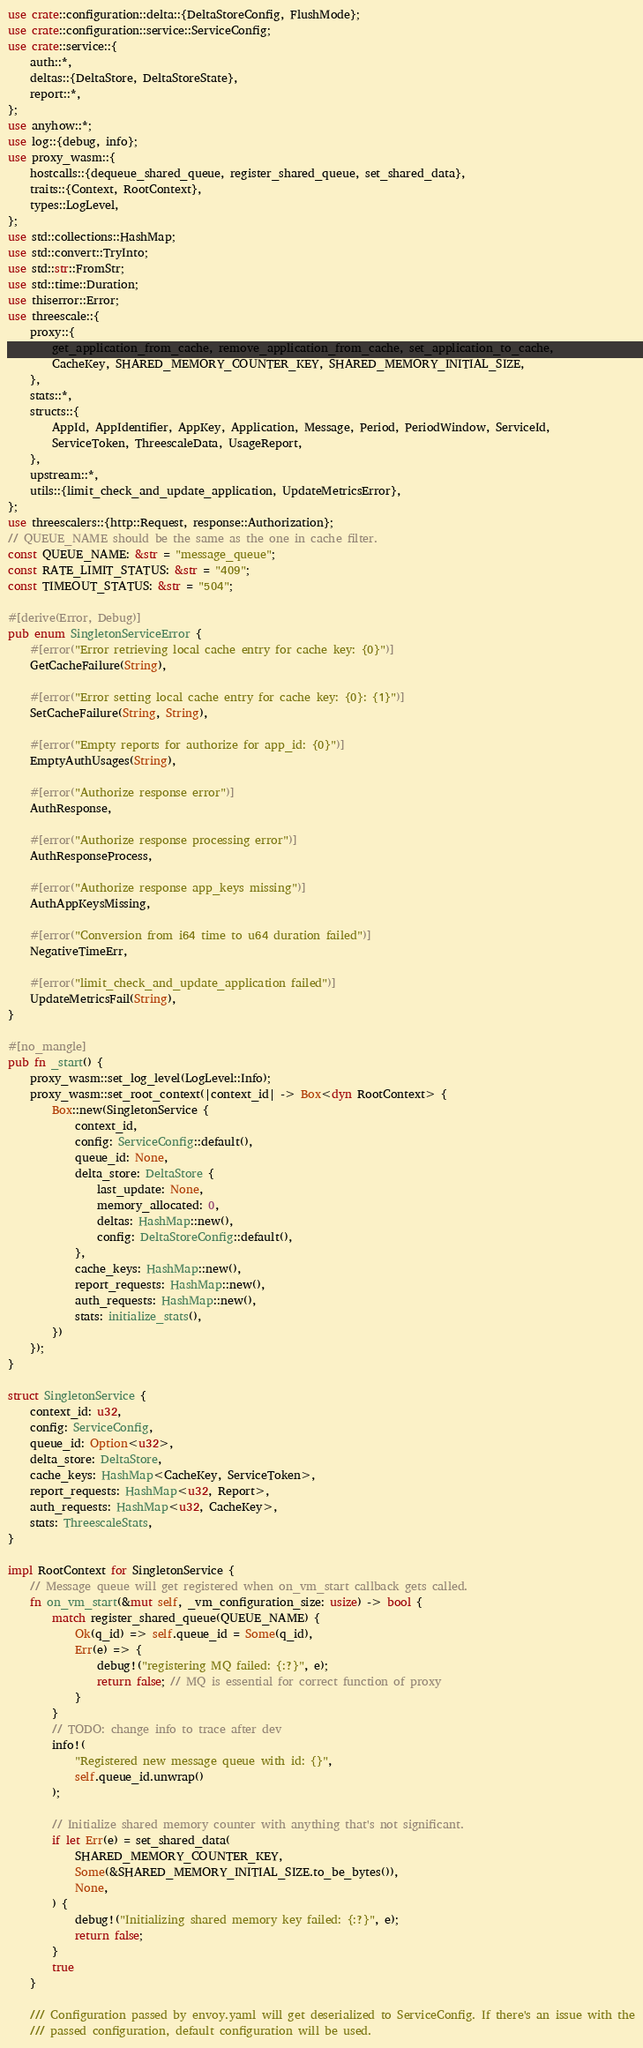<code> <loc_0><loc_0><loc_500><loc_500><_Rust_>use crate::configuration::delta::{DeltaStoreConfig, FlushMode};
use crate::configuration::service::ServiceConfig;
use crate::service::{
    auth::*,
    deltas::{DeltaStore, DeltaStoreState},
    report::*,
};
use anyhow::*;
use log::{debug, info};
use proxy_wasm::{
    hostcalls::{dequeue_shared_queue, register_shared_queue, set_shared_data},
    traits::{Context, RootContext},
    types::LogLevel,
};
use std::collections::HashMap;
use std::convert::TryInto;
use std::str::FromStr;
use std::time::Duration;
use thiserror::Error;
use threescale::{
    proxy::{
        get_application_from_cache, remove_application_from_cache, set_application_to_cache,
        CacheKey, SHARED_MEMORY_COUNTER_KEY, SHARED_MEMORY_INITIAL_SIZE,
    },
    stats::*,
    structs::{
        AppId, AppIdentifier, AppKey, Application, Message, Period, PeriodWindow, ServiceId,
        ServiceToken, ThreescaleData, UsageReport,
    },
    upstream::*,
    utils::{limit_check_and_update_application, UpdateMetricsError},
};
use threescalers::{http::Request, response::Authorization};
// QUEUE_NAME should be the same as the one in cache filter.
const QUEUE_NAME: &str = "message_queue";
const RATE_LIMIT_STATUS: &str = "409";
const TIMEOUT_STATUS: &str = "504";

#[derive(Error, Debug)]
pub enum SingletonServiceError {
    #[error("Error retrieving local cache entry for cache key: {0}")]
    GetCacheFailure(String),

    #[error("Error setting local cache entry for cache key: {0}: {1}")]
    SetCacheFailure(String, String),

    #[error("Empty reports for authorize for app_id: {0}")]
    EmptyAuthUsages(String),

    #[error("Authorize response error")]
    AuthResponse,

    #[error("Authorize response processing error")]
    AuthResponseProcess,

    #[error("Authorize response app_keys missing")]
    AuthAppKeysMissing,

    #[error("Conversion from i64 time to u64 duration failed")]
    NegativeTimeErr,

    #[error("limit_check_and_update_application failed")]
    UpdateMetricsFail(String),
}

#[no_mangle]
pub fn _start() {
    proxy_wasm::set_log_level(LogLevel::Info);
    proxy_wasm::set_root_context(|context_id| -> Box<dyn RootContext> {
        Box::new(SingletonService {
            context_id,
            config: ServiceConfig::default(),
            queue_id: None,
            delta_store: DeltaStore {
                last_update: None,
                memory_allocated: 0,
                deltas: HashMap::new(),
                config: DeltaStoreConfig::default(),
            },
            cache_keys: HashMap::new(),
            report_requests: HashMap::new(),
            auth_requests: HashMap::new(),
            stats: initialize_stats(),
        })
    });
}

struct SingletonService {
    context_id: u32,
    config: ServiceConfig,
    queue_id: Option<u32>,
    delta_store: DeltaStore,
    cache_keys: HashMap<CacheKey, ServiceToken>,
    report_requests: HashMap<u32, Report>,
    auth_requests: HashMap<u32, CacheKey>,
    stats: ThreescaleStats,
}

impl RootContext for SingletonService {
    // Message queue will get registered when on_vm_start callback gets called.
    fn on_vm_start(&mut self, _vm_configuration_size: usize) -> bool {
        match register_shared_queue(QUEUE_NAME) {
            Ok(q_id) => self.queue_id = Some(q_id),
            Err(e) => {
                debug!("registering MQ failed: {:?}", e);
                return false; // MQ is essential for correct function of proxy
            }
        }
        // TODO: change info to trace after dev
        info!(
            "Registered new message queue with id: {}",
            self.queue_id.unwrap()
        );

        // Initialize shared memory counter with anything that's not significant.
        if let Err(e) = set_shared_data(
            SHARED_MEMORY_COUNTER_KEY,
            Some(&SHARED_MEMORY_INITIAL_SIZE.to_be_bytes()),
            None,
        ) {
            debug!("Initializing shared memory key failed: {:?}", e);
            return false;
        }
        true
    }

    /// Configuration passed by envoy.yaml will get deserialized to ServiceConfig. If there's an issue with the
    /// passed configuration, default configuration will be used.</code> 